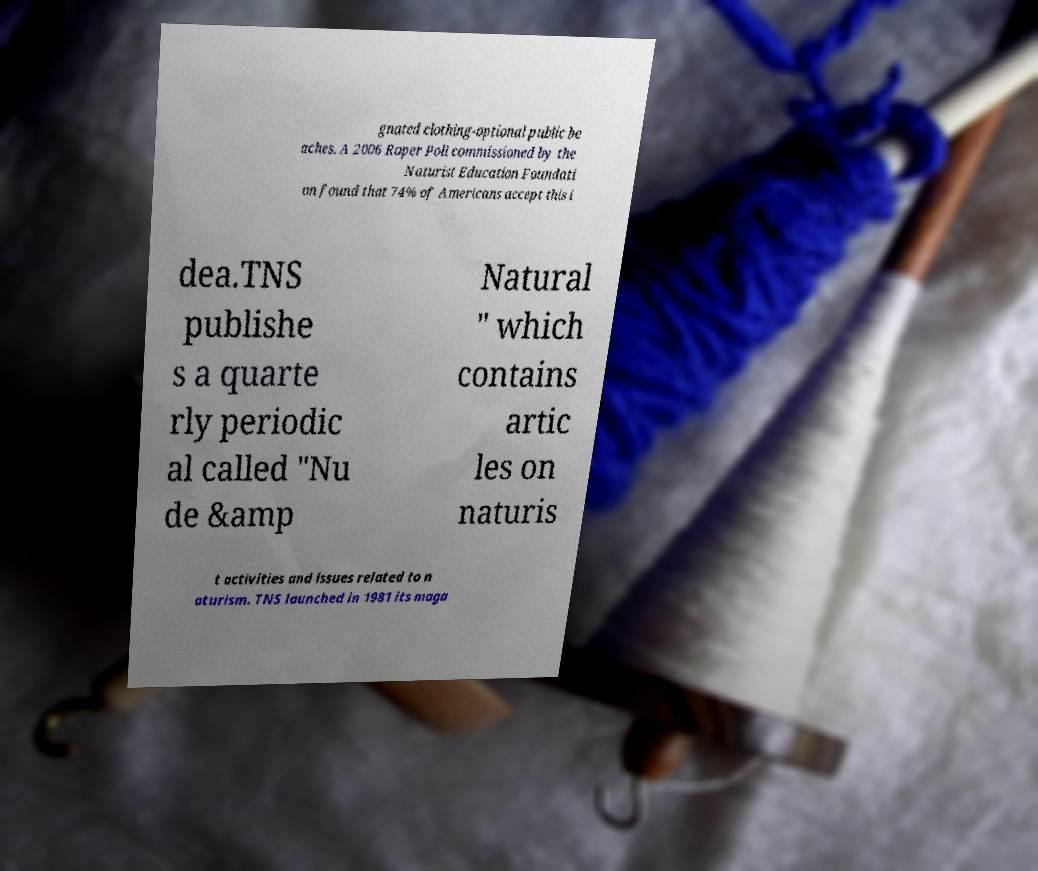Please read and relay the text visible in this image. What does it say? gnated clothing-optional public be aches. A 2006 Roper Poll commissioned by the Naturist Education Foundati on found that 74% of Americans accept this i dea.TNS publishe s a quarte rly periodic al called "Nu de &amp Natural " which contains artic les on naturis t activities and issues related to n aturism. TNS launched in 1981 its maga 